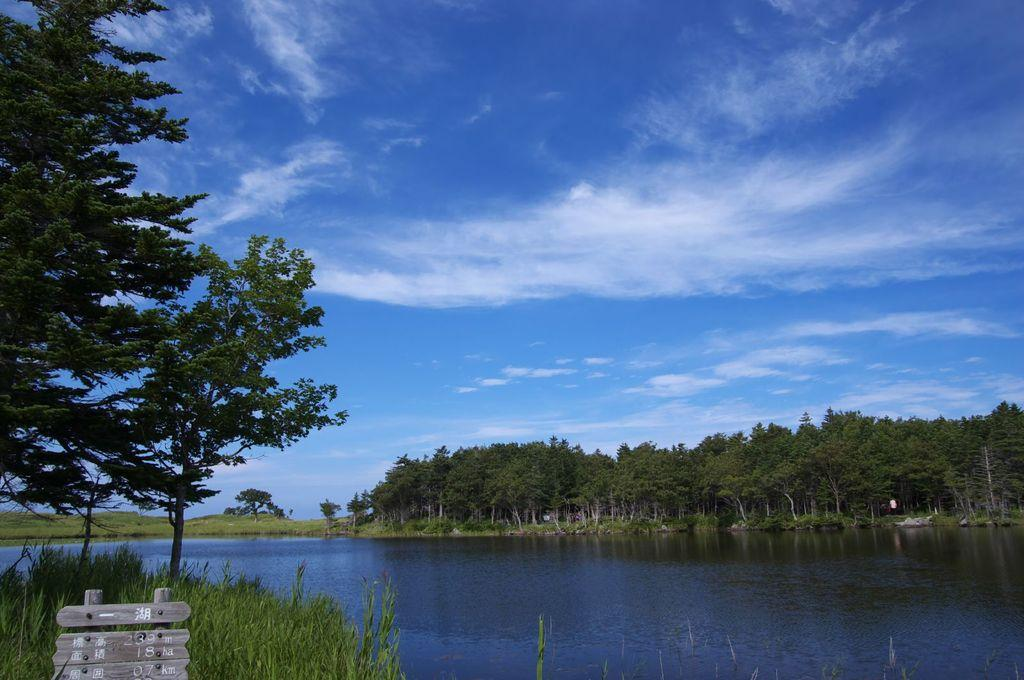What body of water is visible in the image? There is a lake in the image. What type of vegetation can be seen in the background of the image? There are trees in the background of the image. What color is the sky in the background of the image? The sky is blue in the background of the image. What object is located in the bottom left of the image? There is a wooden board in the bottom left of the image. What is written or depicted on the wooden board? There is text on the wooden board. What type of glass is being used to control the speed of the vehicle in the image? There is no vehicle or glass present in the image; it features a lake, trees, a blue sky, and a wooden board with text. 